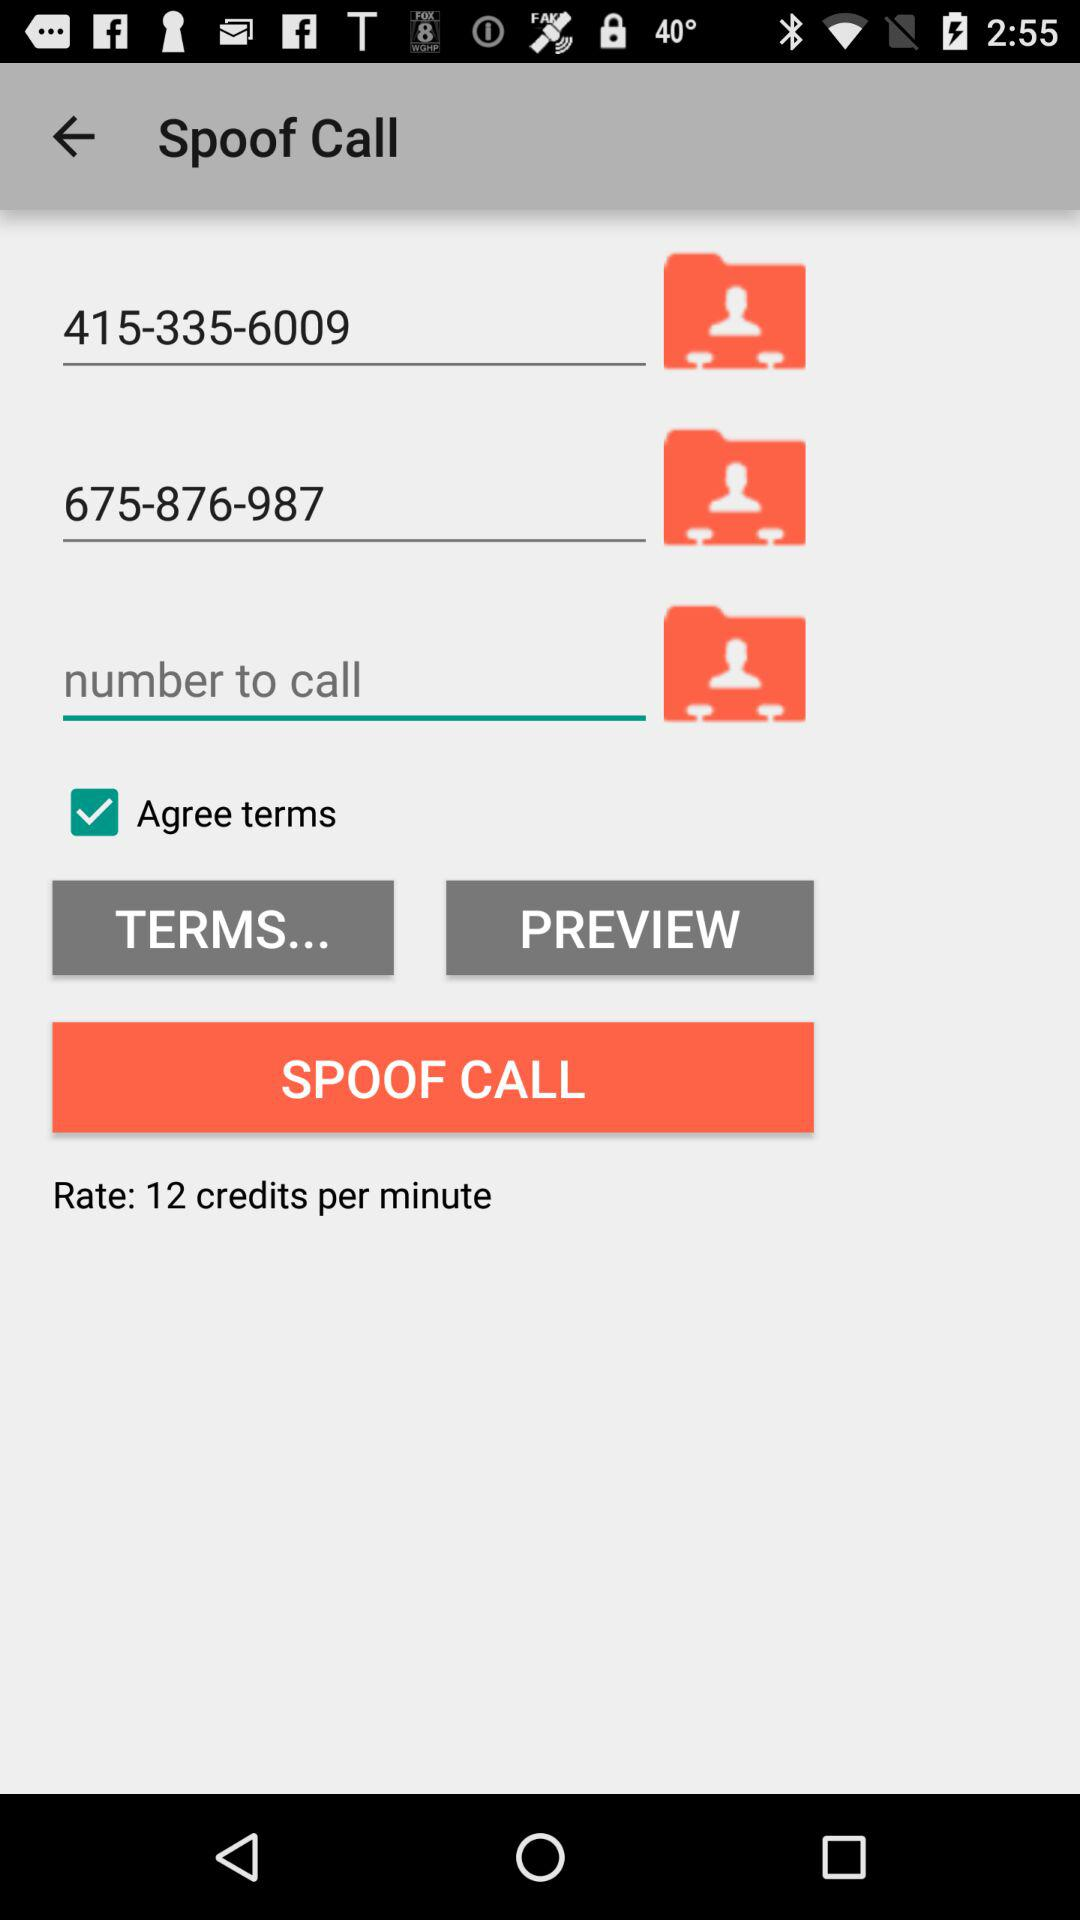What are the mentioned numbers? The mentioned numbers are 415-335-6009 and 675-876-987. 